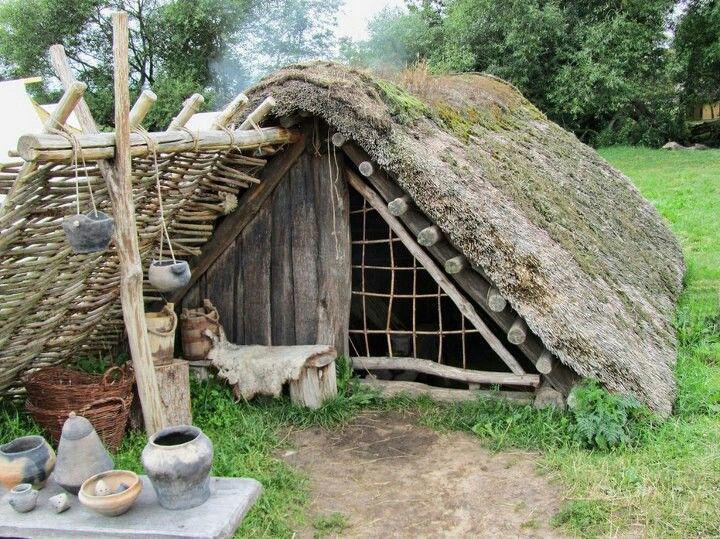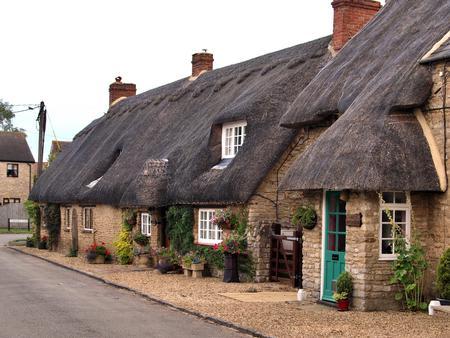The first image is the image on the left, the second image is the image on the right. For the images displayed, is the sentence "In at least one image there is a building with a black hay roof." factually correct? Answer yes or no. Yes. The first image is the image on the left, the second image is the image on the right. Analyze the images presented: Is the assertion "One house is shaped like a triangle." valid? Answer yes or no. Yes. 